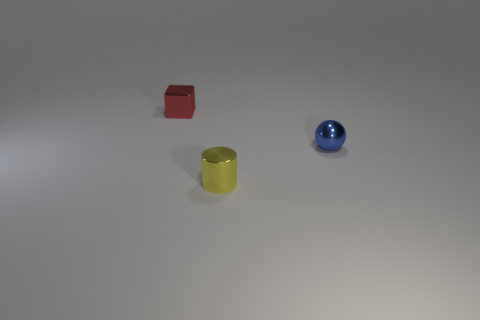Add 1 small blue shiny cylinders. How many objects exist? 4 Subtract all cylinders. How many objects are left? 2 Subtract all yellow blocks. Subtract all cyan cylinders. How many blocks are left? 1 Subtract all large gray matte cylinders. Subtract all small red metal things. How many objects are left? 2 Add 2 blue metallic objects. How many blue metallic objects are left? 3 Add 2 blue metallic spheres. How many blue metallic spheres exist? 3 Subtract 0 purple cylinders. How many objects are left? 3 